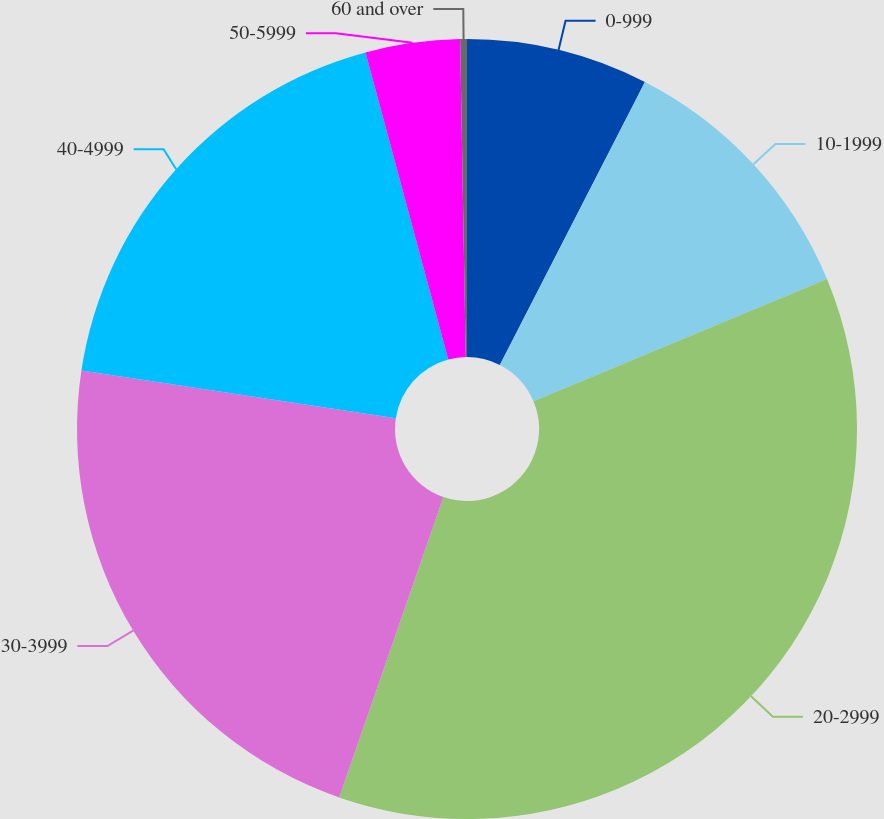<chart> <loc_0><loc_0><loc_500><loc_500><pie_chart><fcel>0-999<fcel>10-1999<fcel>20-2999<fcel>30-3999<fcel>40-4999<fcel>50-5999<fcel>60 and over<nl><fcel>7.54%<fcel>11.17%<fcel>36.6%<fcel>22.08%<fcel>18.41%<fcel>3.91%<fcel>0.28%<nl></chart> 